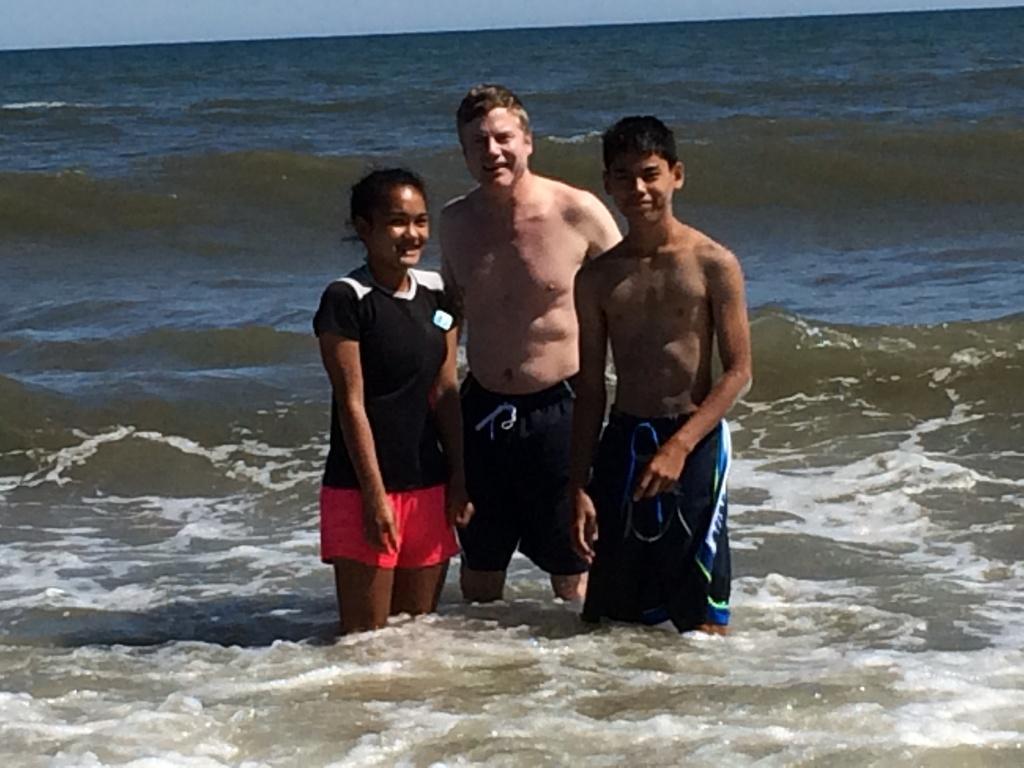Please provide a concise description of this image. In this image, there are three persons standing in the water and smiling. At the top of the image, there is the sky. 